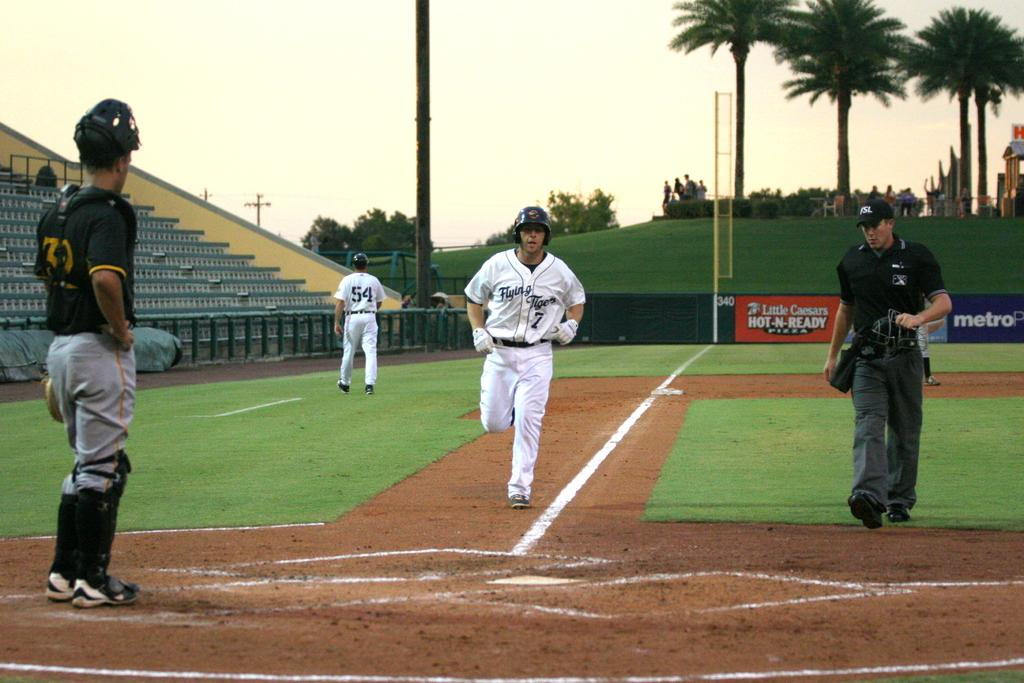<image>
Share a concise interpretation of the image provided. A baseball player is running for a base in a stadium with a Little Caesars sign. 